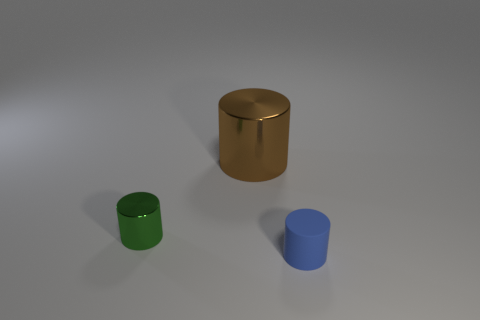What number of other large metallic objects are the same shape as the brown metal thing?
Provide a short and direct response. 0. Does the big shiny cylinder have the same color as the small shiny cylinder?
Make the answer very short. No. Are there fewer small blue matte things than tiny cyan cylinders?
Your answer should be compact. No. What material is the cylinder that is behind the tiny green metal cylinder?
Provide a succinct answer. Metal. What material is the thing that is the same size as the green shiny cylinder?
Keep it short and to the point. Rubber. What is the cylinder to the left of the metallic cylinder that is behind the tiny thing that is behind the tiny blue object made of?
Provide a short and direct response. Metal. Do the thing right of the brown object and the green cylinder have the same size?
Provide a short and direct response. Yes. Is the number of shiny cylinders greater than the number of large green metal objects?
Provide a succinct answer. Yes. What number of small things are green cylinders or matte things?
Make the answer very short. 2. How many other things are there of the same color as the matte thing?
Your response must be concise. 0. 